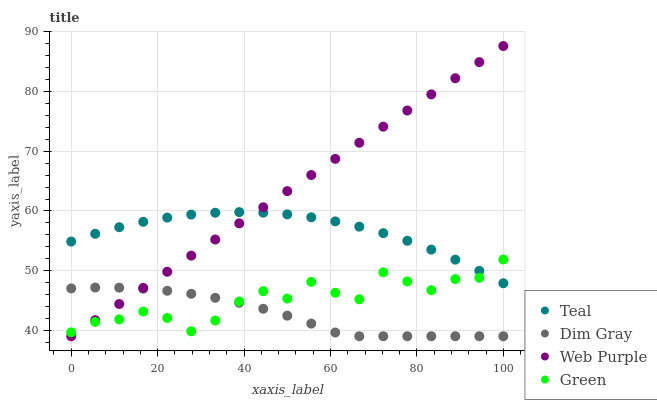Does Dim Gray have the minimum area under the curve?
Answer yes or no. Yes. Does Web Purple have the maximum area under the curve?
Answer yes or no. Yes. Does Green have the minimum area under the curve?
Answer yes or no. No. Does Green have the maximum area under the curve?
Answer yes or no. No. Is Web Purple the smoothest?
Answer yes or no. Yes. Is Green the roughest?
Answer yes or no. Yes. Is Dim Gray the smoothest?
Answer yes or no. No. Is Dim Gray the roughest?
Answer yes or no. No. Does Web Purple have the lowest value?
Answer yes or no. Yes. Does Green have the lowest value?
Answer yes or no. No. Does Web Purple have the highest value?
Answer yes or no. Yes. Does Green have the highest value?
Answer yes or no. No. Is Dim Gray less than Teal?
Answer yes or no. Yes. Is Teal greater than Dim Gray?
Answer yes or no. Yes. Does Green intersect Web Purple?
Answer yes or no. Yes. Is Green less than Web Purple?
Answer yes or no. No. Is Green greater than Web Purple?
Answer yes or no. No. Does Dim Gray intersect Teal?
Answer yes or no. No. 